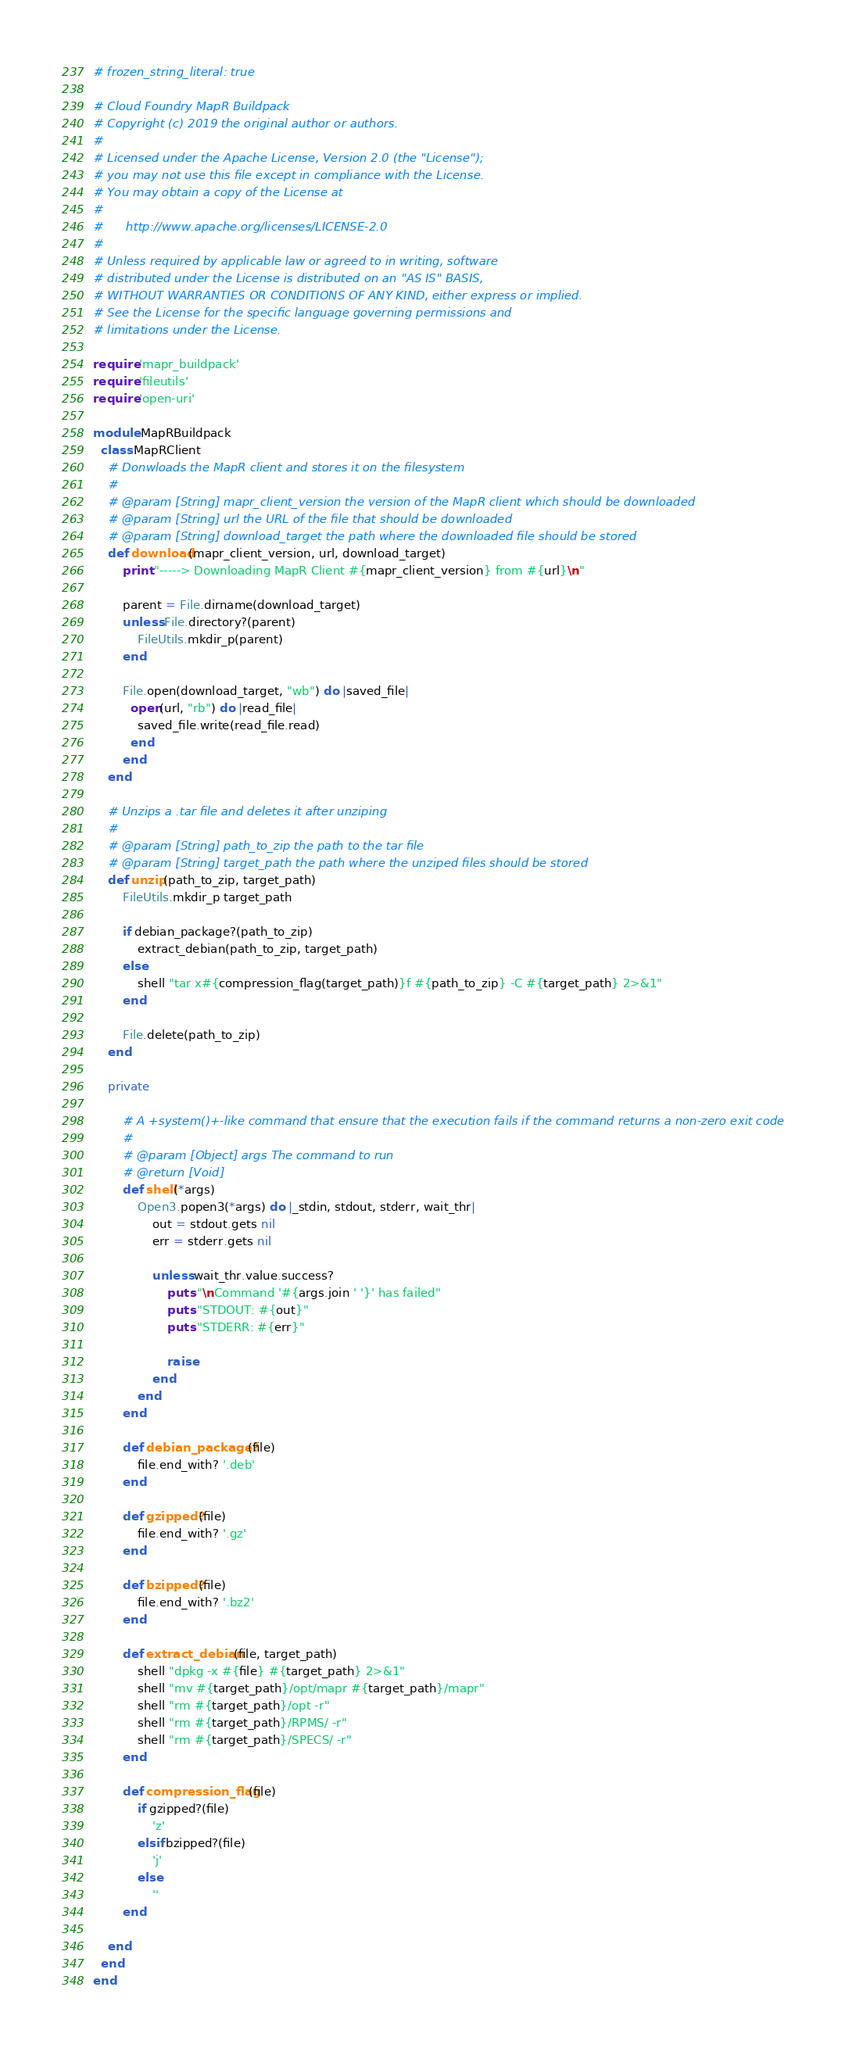Convert code to text. <code><loc_0><loc_0><loc_500><loc_500><_Ruby_># frozen_string_literal: true

# Cloud Foundry MapR Buildpack
# Copyright (c) 2019 the original author or authors.
#
# Licensed under the Apache License, Version 2.0 (the "License");
# you may not use this file except in compliance with the License.
# You may obtain a copy of the License at
#
#      http://www.apache.org/licenses/LICENSE-2.0
#
# Unless required by applicable law or agreed to in writing, software
# distributed under the License is distributed on an "AS IS" BASIS,
# WITHOUT WARRANTIES OR CONDITIONS OF ANY KIND, either express or implied.
# See the License for the specific language governing permissions and
# limitations under the License.

require 'mapr_buildpack'
require 'fileutils'
require 'open-uri'

module MapRBuildpack
  class MapRClient
    # Donwloads the MapR client and stores it on the filesystem
    # 
    # @param [String] mapr_client_version the version of the MapR client which should be downloaded
    # @param [String] url the URL of the file that should be downloaded
    # @param [String] download_target the path where the downloaded file should be stored
    def download(mapr_client_version, url, download_target)
        print "-----> Downloading MapR Client #{mapr_client_version} from #{url}\n"

        parent = File.dirname(download_target)
        unless File.directory?(parent)
            FileUtils.mkdir_p(parent)
        end

        File.open(download_target, "wb") do |saved_file|
          open(url, "rb") do |read_file|
            saved_file.write(read_file.read)
          end
        end
    end

    # Unzips a .tar file and deletes it after unziping
    # 
    # @param [String] path_to_zip the path to the tar file
    # @param [String] target_path the path where the unziped files should be stored
    def unzip(path_to_zip, target_path)
        FileUtils.mkdir_p target_path

        if debian_package?(path_to_zip)
            extract_debian(path_to_zip, target_path)
        else
            shell "tar x#{compression_flag(target_path)}f #{path_to_zip} -C #{target_path} 2>&1"
        end

        File.delete(path_to_zip)
    end

    private

        # A +system()+-like command that ensure that the execution fails if the command returns a non-zero exit code
        #
        # @param [Object] args The command to run
        # @return [Void]
        def shell(*args)
            Open3.popen3(*args) do |_stdin, stdout, stderr, wait_thr|
                out = stdout.gets nil
                err = stderr.gets nil

                unless wait_thr.value.success?
                    puts "\nCommand '#{args.join ' '}' has failed"
                    puts "STDOUT: #{out}"
                    puts "STDERR: #{err}"

                    raise
                end
            end
        end

        def debian_package?(file)
            file.end_with? '.deb'
        end

        def gzipped?(file)
            file.end_with? '.gz'
        end

        def bzipped?(file)
            file.end_with? '.bz2'
        end

        def extract_debian(file, target_path)
            shell "dpkg -x #{file} #{target_path} 2>&1"
            shell "mv #{target_path}/opt/mapr #{target_path}/mapr"
            shell "rm #{target_path}/opt -r"
            shell "rm #{target_path}/RPMS/ -r"
            shell "rm #{target_path}/SPECS/ -r"
        end

        def compression_flag(file)
            if gzipped?(file)
                'z'
            elsif bzipped?(file)
                'j'
            else
                ''
        end

    end
  end
end</code> 